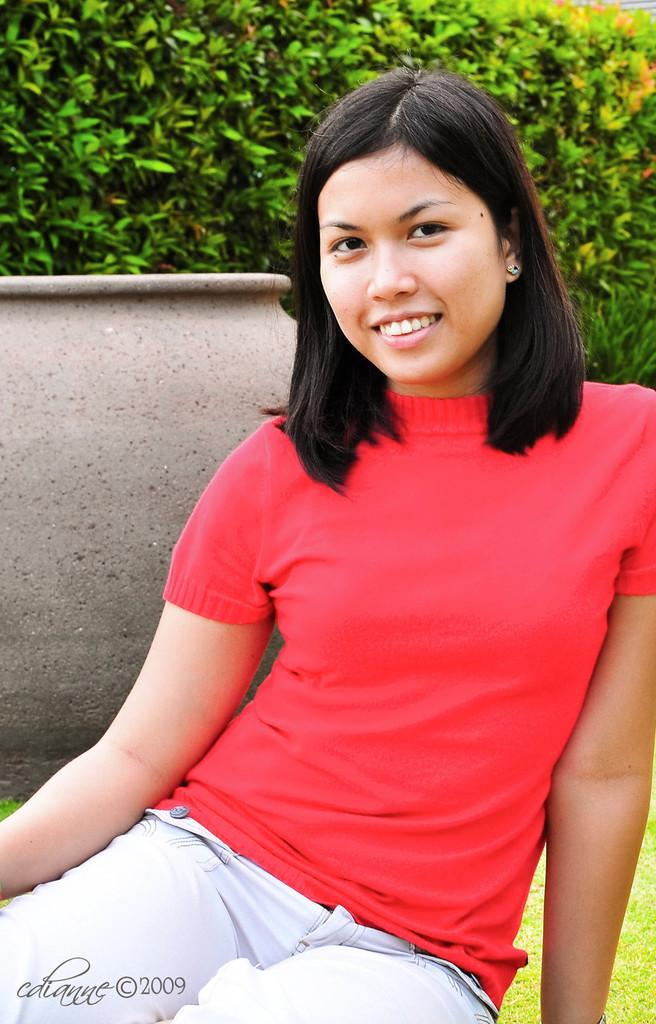What can be seen in the image? There is a person in the image. What is the ground covered with? The ground is covered with grass. Can you describe the object in the image? There is an object in the image, but its specific details are not mentioned in the facts. Are there any plants visible in the image? Yes, there are a few plants in the image. What type of stove can be seen in the aftermath of the plane crash in the image? There is no stove, plane crash, or any mention of an aftermath in the image. The image only contains a person, grass-covered ground, an object, and a few plants. 